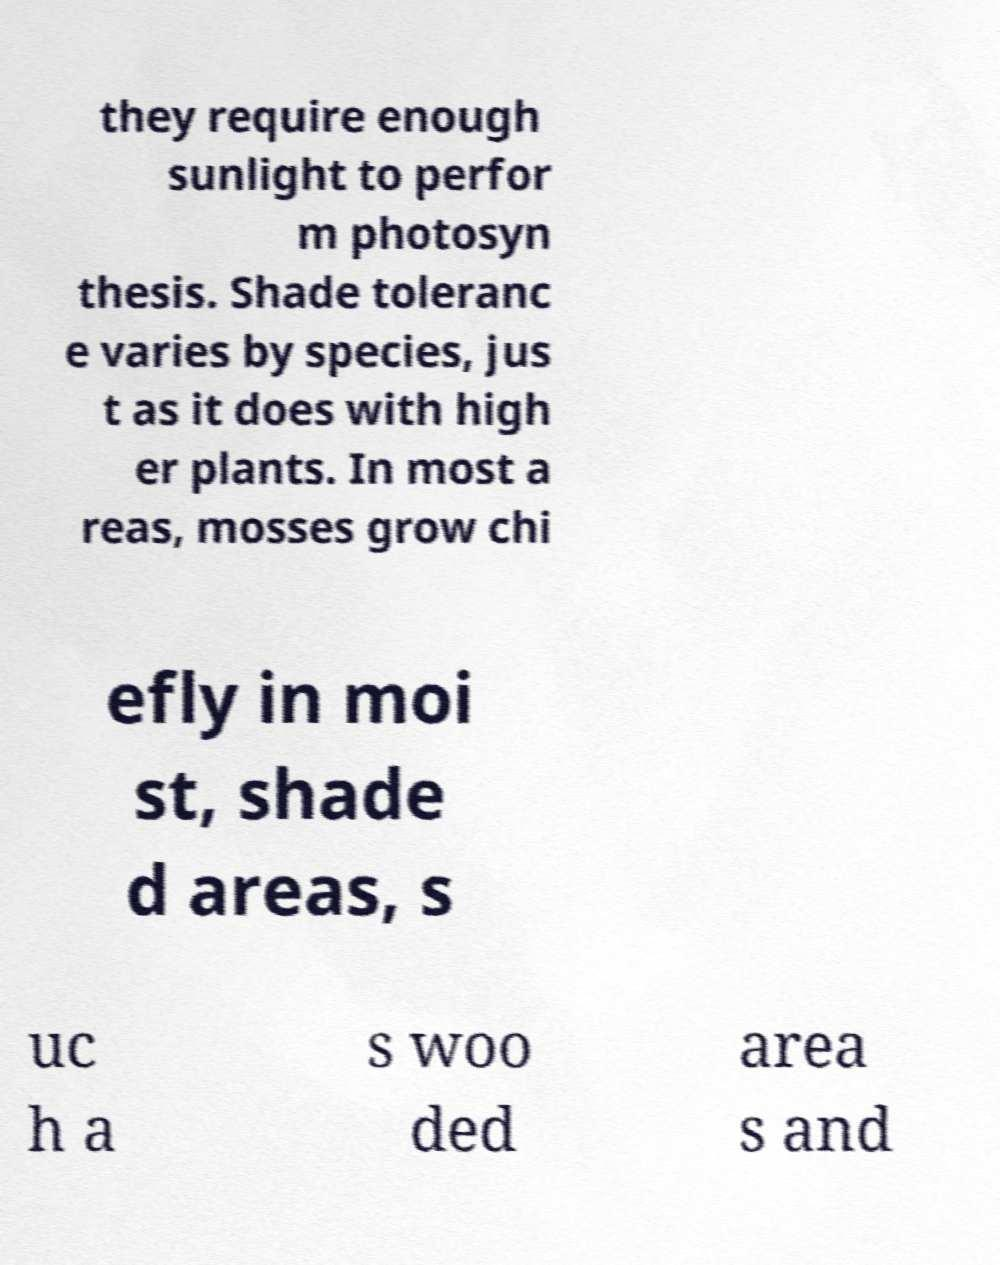For documentation purposes, I need the text within this image transcribed. Could you provide that? they require enough sunlight to perfor m photosyn thesis. Shade toleranc e varies by species, jus t as it does with high er plants. In most a reas, mosses grow chi efly in moi st, shade d areas, s uc h a s woo ded area s and 